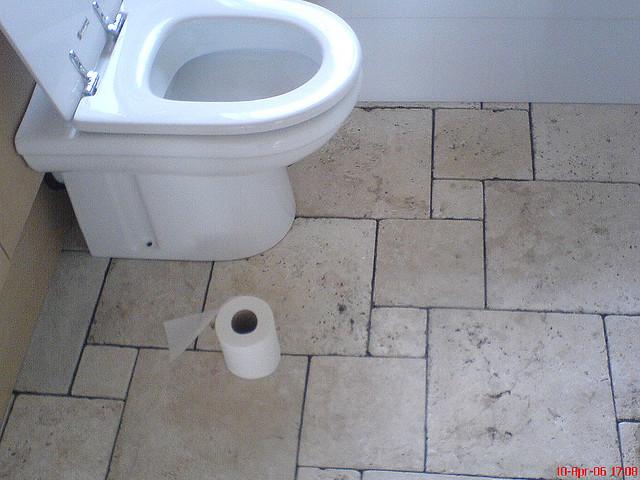Is there a toilet seat attached?
Quick response, please. Yes. Is the roll on the right of the bowl or on the left?
Write a very short answer. Right. What is the floor made of?
Quick response, please. Tile. What would you use the roll for?
Be succinct. Wiping. 